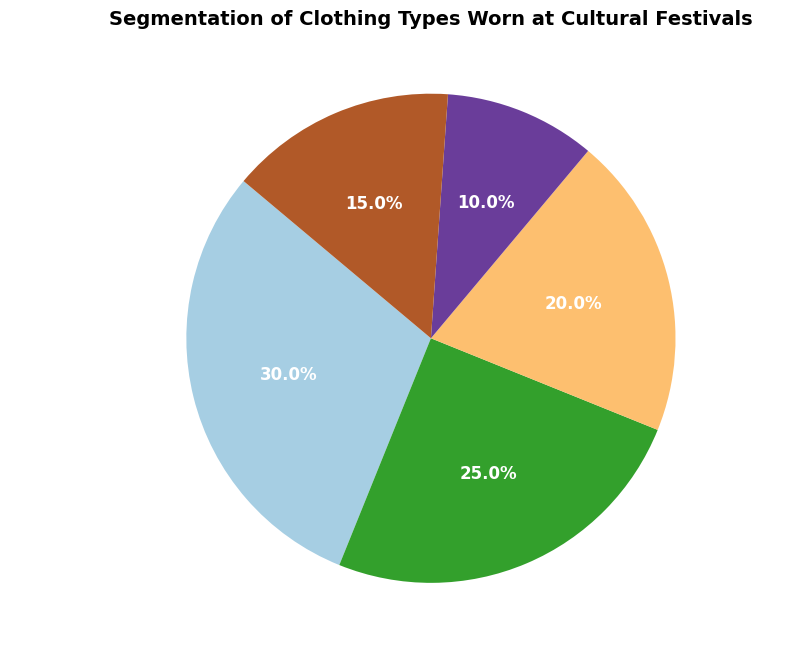What is the most common type of clothing worn at cultural festivals? The pie chart shows the largest segment, which is for Traditional Attire. Thus, Traditional Attire is the most common clothing type.
Answer: Traditional Attire What percentage of people wear Formal Wear and Ethnic Fusion combined? To find the combined percentage, add the percentages of Formal Wear (10%) and Ethnic Fusion (15%). 10% + 15% = 25%
Answer: 25% Is there a greater percentage of people wearing Modern Casual Wear than Costumes? The pie chart shows Modern Casual Wear at 25% and Costumes at 20%. Since 25% is greater than 20%, more people wear Modern Casual Wear than Costumes.
Answer: Yes Which category has the smallest percentage of clothing worn? The pie chart shows that the smallest segment is for Formal Wear, which is 10%.
Answer: Formal Wear What is the total percentage of people not wearing Traditional Attire? Subtract the percentage of Traditional Attire (30%) from 100%. 100% - 30% = 70%
Answer: 70% What is the percentage difference between Traditional Attire and Costumes? Subtract the percentage of Costumes (20%) from Traditional Attire (30%). 30% - 20% = 10%
Answer: 10% Order the clothing types from most to least worn. From the pie chart, the segments in decreasing order are: Traditional Attire (30%), Modern Casual Wear (25%), Costumes (20%), Ethnic Fusion (15%), Formal Wear (10%).
Answer: Traditional Attire, Modern Casual Wear, Costumes, Ethnic Fusion, Formal Wear If you combine Modern Casual Wear and Costumes, do they cover more than half of the total percentage? Add the percentages of Modern Casual Wear (25%) and Costumes (20%). 25% + 20% = 45%, which is less than 50%.
Answer: No What fraction of people wear ethnic-related clothing (Traditional Attire and Ethnic Fusion) compared to the total? Add the percentages of Traditional Attire (30%) and Ethnic Fusion (15%). 30% + 15% = 45%, making the fraction 45/100 or 9/20.
Answer: 9/20 